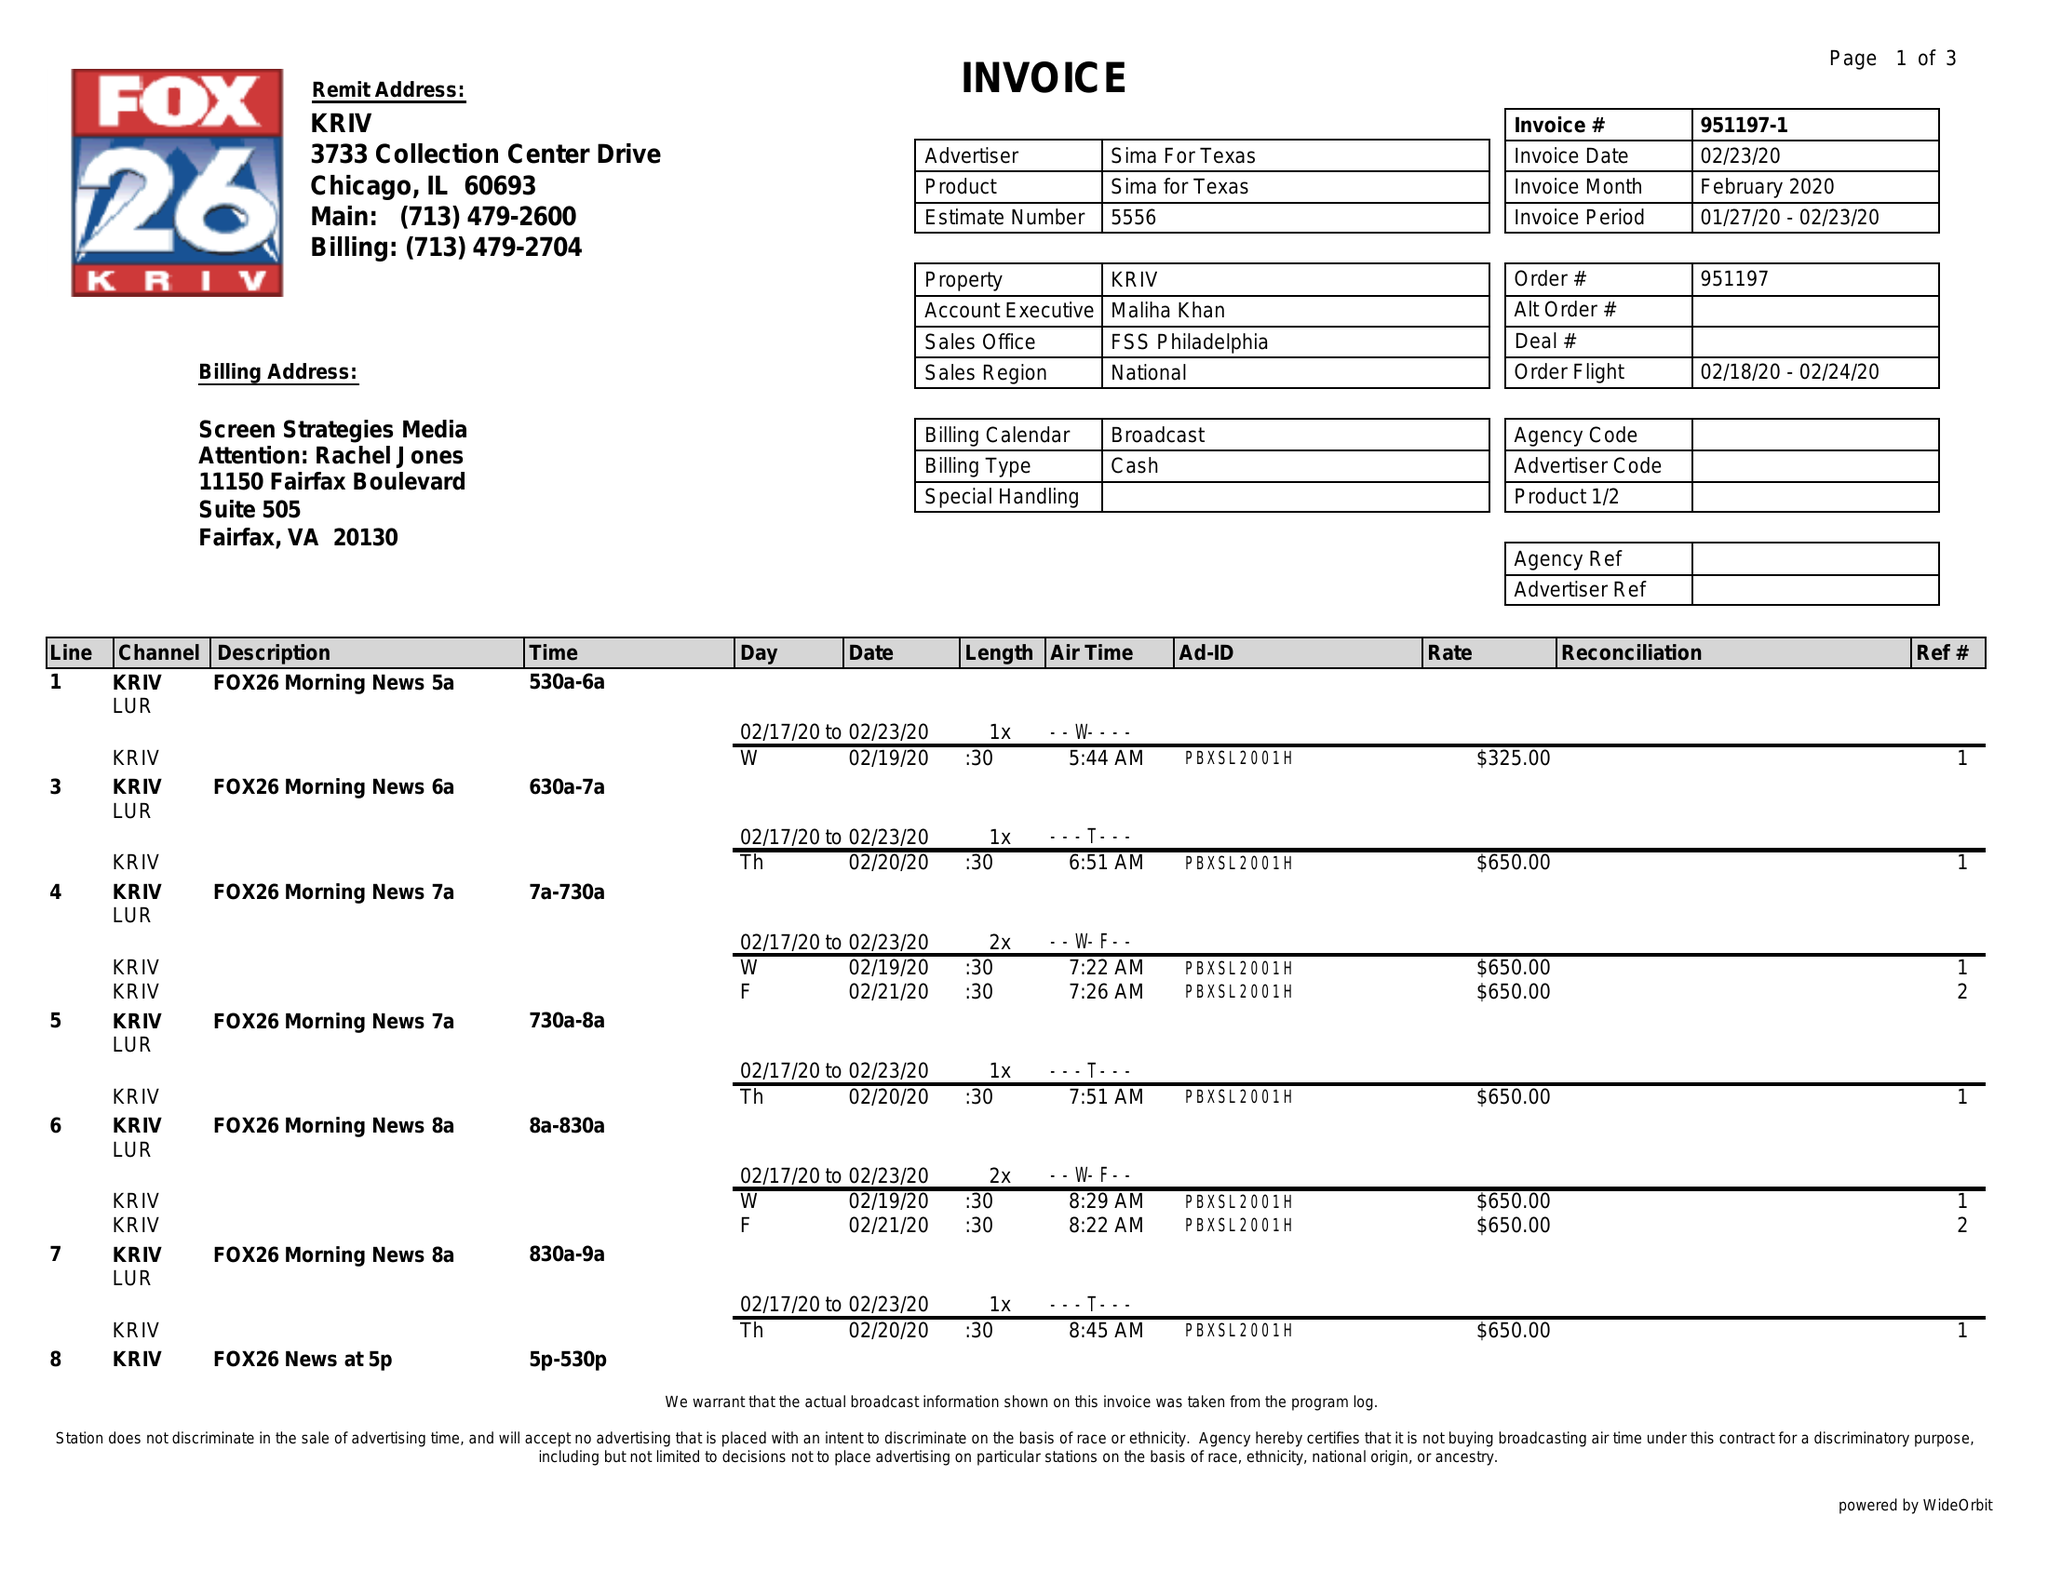What is the value for the flight_from?
Answer the question using a single word or phrase. 02/18/20 